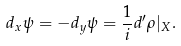<formula> <loc_0><loc_0><loc_500><loc_500>d _ { x } \psi = - d _ { y } \psi = \frac { 1 } { i } d ^ { \prime } \rho | _ { X } .</formula> 